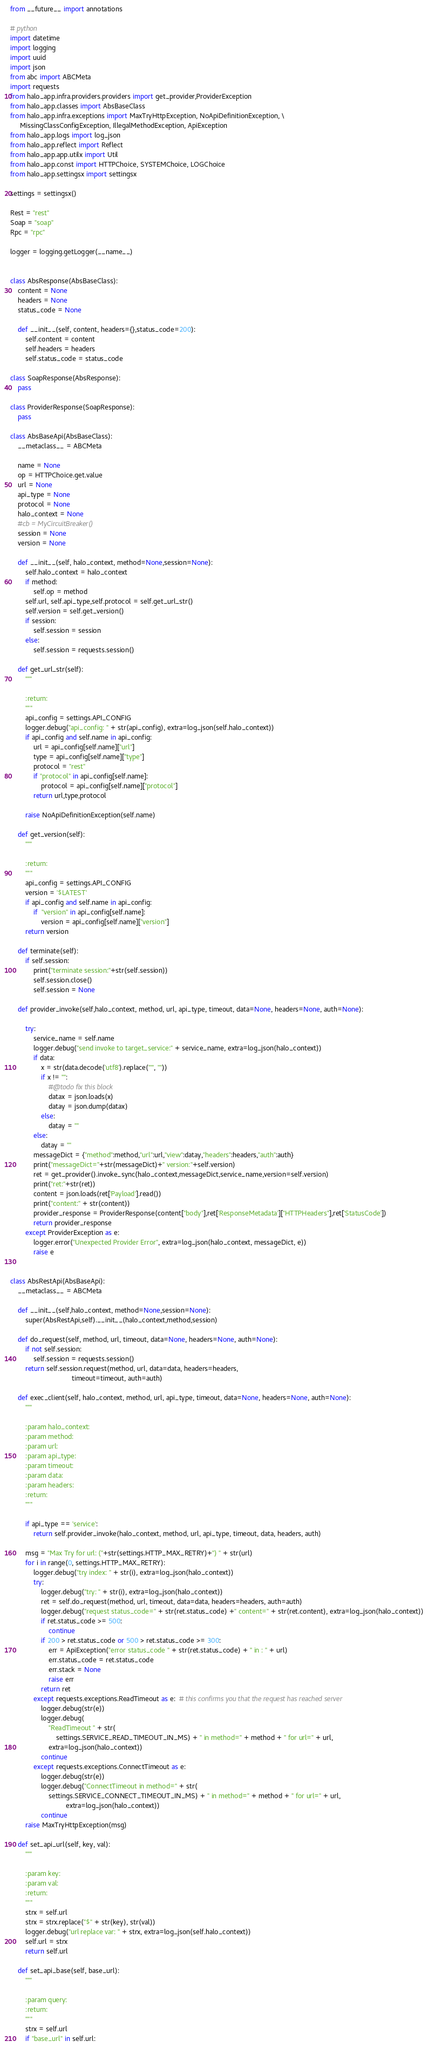<code> <loc_0><loc_0><loc_500><loc_500><_Python_>from __future__ import annotations

# python
import datetime
import logging
import uuid
import json
from abc import ABCMeta
import requests
from halo_app.infra.providers.providers import get_provider,ProviderException
from halo_app.classes import AbsBaseClass
from halo_app.infra.exceptions import MaxTryHttpException, NoApiDefinitionException, \
     MissingClassConfigException, IllegalMethodException, ApiException
from halo_app.logs import log_json
from halo_app.reflect import Reflect
from halo_app.app.utilx import Util
from halo_app.const import HTTPChoice, SYSTEMChoice, LOGChoice
from halo_app.settingsx import settingsx

settings = settingsx()

Rest = "rest"
Soap = "soap"
Rpc = "rpc"

logger = logging.getLogger(__name__)


class AbsResponse(AbsBaseClass):
    content = None
    headers = None
    status_code = None

    def __init__(self, content, headers={},status_code=200):
        self.content = content
        self.headers = headers
        self.status_code = status_code

class SoapResponse(AbsResponse):
    pass

class ProviderResponse(SoapResponse):
    pass

class AbsBaseApi(AbsBaseClass):
    __metaclass__ = ABCMeta

    name = None
    op = HTTPChoice.get.value
    url = None
    api_type = None
    protocol = None
    halo_context = None
    #cb = MyCircuitBreaker()
    session = None
    version = None

    def __init__(self, halo_context, method=None,session=None):
        self.halo_context = halo_context
        if method:
            self.op = method
        self.url, self.api_type,self.protocol = self.get_url_str()
        self.version = self.get_version()
        if session:
            self.session = session
        else:
            self.session = requests.session()

    def get_url_str(self):
        """

        :return:
        """
        api_config = settings.API_CONFIG
        logger.debug("api_config: " + str(api_config), extra=log_json(self.halo_context))
        if api_config and self.name in api_config:
            url = api_config[self.name]["url"]
            type = api_config[self.name]["type"]
            protocol = "rest"
            if "protocol" in api_config[self.name]:
                protocol = api_config[self.name]["protocol"]
            return url,type,protocol

        raise NoApiDefinitionException(self.name)

    def get_version(self):
        """

        :return:
        """
        api_config = settings.API_CONFIG
        version = '$LATEST'
        if api_config and self.name in api_config:
            if  "version" in api_config[self.name]:
                version = api_config[self.name]["version"]
        return version

    def terminate(self):
        if self.session:
            print("terminate session:"+str(self.session))
            self.session.close()
            self.session = None

    def provider_invoke(self,halo_context, method, url, api_type, timeout, data=None, headers=None, auth=None):

        try:
            service_name = self.name
            logger.debug("send invoke to target_service:" + service_name, extra=log_json(halo_context))
            if data:
                x = str(data.decode('utf8').replace("'", '"'))
                if x != "":
                    #@todo fix this block
                    datax = json.loads(x)
                    datay = json.dump(datax)
                else:
                    datay = ""
            else:
                datay = ""
            messageDict = {"method":method,"url":url,"view":datay,"headers":headers,"auth":auth}
            print("messageDict="+str(messageDict)+" version:"+self.version)
            ret = get_provider().invoke_sync(halo_context,messageDict,service_name,version=self.version)
            print("ret:"+str(ret))
            content = json.loads(ret['Payload'].read())
            print("content:" + str(content))
            provider_response = ProviderResponse(content["body"],ret['ResponseMetadata']["HTTPHeaders"],ret['StatusCode'])
            return provider_response
        except ProviderException as e:
            logger.error("Unexpected Provider Error", extra=log_json(halo_context, messageDict, e))
            raise e


class AbsRestApi(AbsBaseApi):
    __metaclass__ = ABCMeta

    def __init__(self,halo_context, method=None,session=None):
        super(AbsRestApi,self).__init__(halo_context,method,session)

    def do_request(self, method, url, timeout, data=None, headers=None, auth=None):
        if not self.session:
            self.session = requests.session()
        return self.session.request(method, url, data=data, headers=headers,
                                timeout=timeout, auth=auth)

    def exec_client(self, halo_context, method, url, api_type, timeout, data=None, headers=None, auth=None):
        """

        :param halo_context:
        :param method:
        :param url:
        :param api_type:
        :param timeout:
        :param data:
        :param headers:
        :return:
        """

        if api_type == 'service':
            return self.provider_invoke(halo_context, method, url, api_type, timeout, data, headers, auth)

        msg = "Max Try for url: ("+str(settings.HTTP_MAX_RETRY)+") " + str(url)
        for i in range(0, settings.HTTP_MAX_RETRY):
            logger.debug("try index: " + str(i), extra=log_json(halo_context))
            try:
                logger.debug("try: " + str(i), extra=log_json(halo_context))
                ret = self.do_request(method, url, timeout, data=data, headers=headers, auth=auth)
                logger.debug("request status_code=" + str(ret.status_code) +" content=" + str(ret.content), extra=log_json(halo_context))
                if ret.status_code >= 500:
                    continue
                if 200 > ret.status_code or 500 > ret.status_code >= 300:
                    err = ApiException("error status_code " + str(ret.status_code) + " in : " + url)
                    err.status_code = ret.status_code
                    err.stack = None
                    raise err
                return ret
            except requests.exceptions.ReadTimeout as e:  # this confirms you that the request has reached server
                logger.debug(str(e))
                logger.debug(
                    "ReadTimeout " + str(
                        settings.SERVICE_READ_TIMEOUT_IN_MS) + " in method=" + method + " for url=" + url,
                    extra=log_json(halo_context))
                continue
            except requests.exceptions.ConnectTimeout as e:
                logger.debug(str(e))
                logger.debug("ConnectTimeout in method=" + str(
                    settings.SERVICE_CONNECT_TIMEOUT_IN_MS) + " in method=" + method + " for url=" + url,
                             extra=log_json(halo_context))
                continue
        raise MaxTryHttpException(msg)

    def set_api_url(self, key, val):
        """

        :param key:
        :param val:
        :return:
        """
        strx = self.url
        strx = strx.replace("$" + str(key), str(val))
        logger.debug("url replace var: " + strx, extra=log_json(self.halo_context))
        self.url = strx
        return self.url

    def set_api_base(self, base_url):
        """

        :param query:
        :return:
        """
        strx = self.url
        if "base_url" in self.url:</code> 